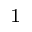<formula> <loc_0><loc_0><loc_500><loc_500>^ { 1 }</formula> 